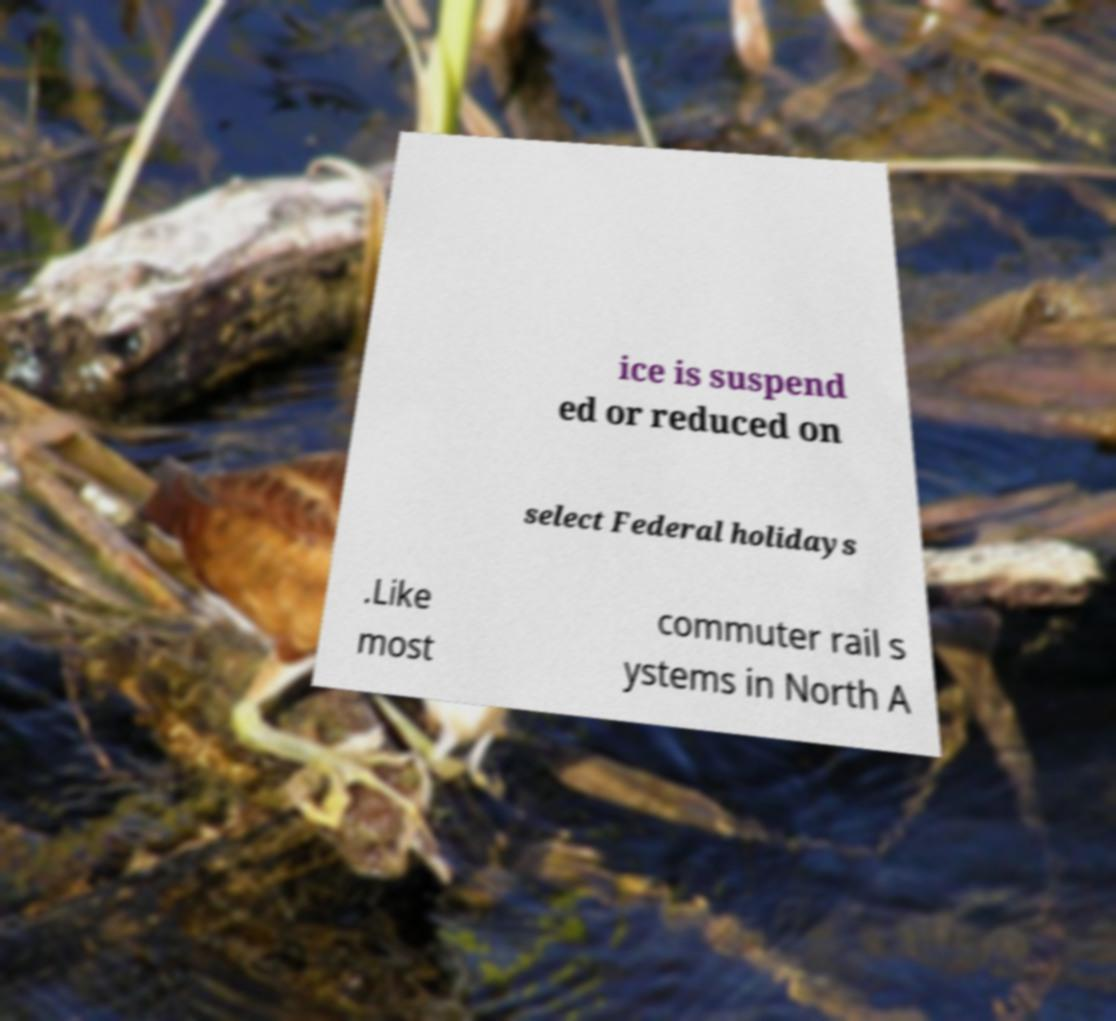Could you assist in decoding the text presented in this image and type it out clearly? ice is suspend ed or reduced on select Federal holidays .Like most commuter rail s ystems in North A 